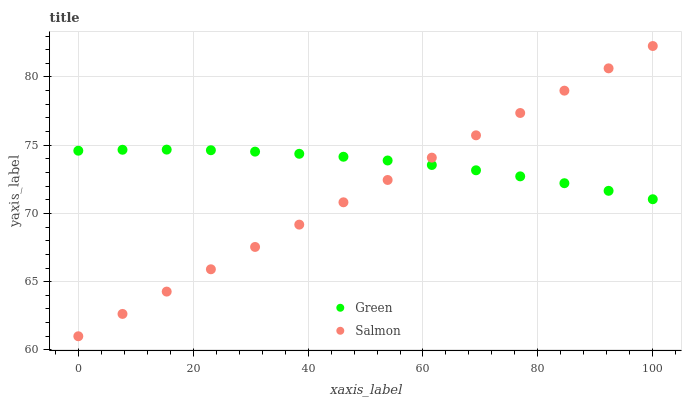Does Salmon have the minimum area under the curve?
Answer yes or no. Yes. Does Green have the maximum area under the curve?
Answer yes or no. Yes. Does Green have the minimum area under the curve?
Answer yes or no. No. Is Salmon the smoothest?
Answer yes or no. Yes. Is Green the roughest?
Answer yes or no. Yes. Is Green the smoothest?
Answer yes or no. No. Does Salmon have the lowest value?
Answer yes or no. Yes. Does Green have the lowest value?
Answer yes or no. No. Does Salmon have the highest value?
Answer yes or no. Yes. Does Green have the highest value?
Answer yes or no. No. Does Salmon intersect Green?
Answer yes or no. Yes. Is Salmon less than Green?
Answer yes or no. No. Is Salmon greater than Green?
Answer yes or no. No. 